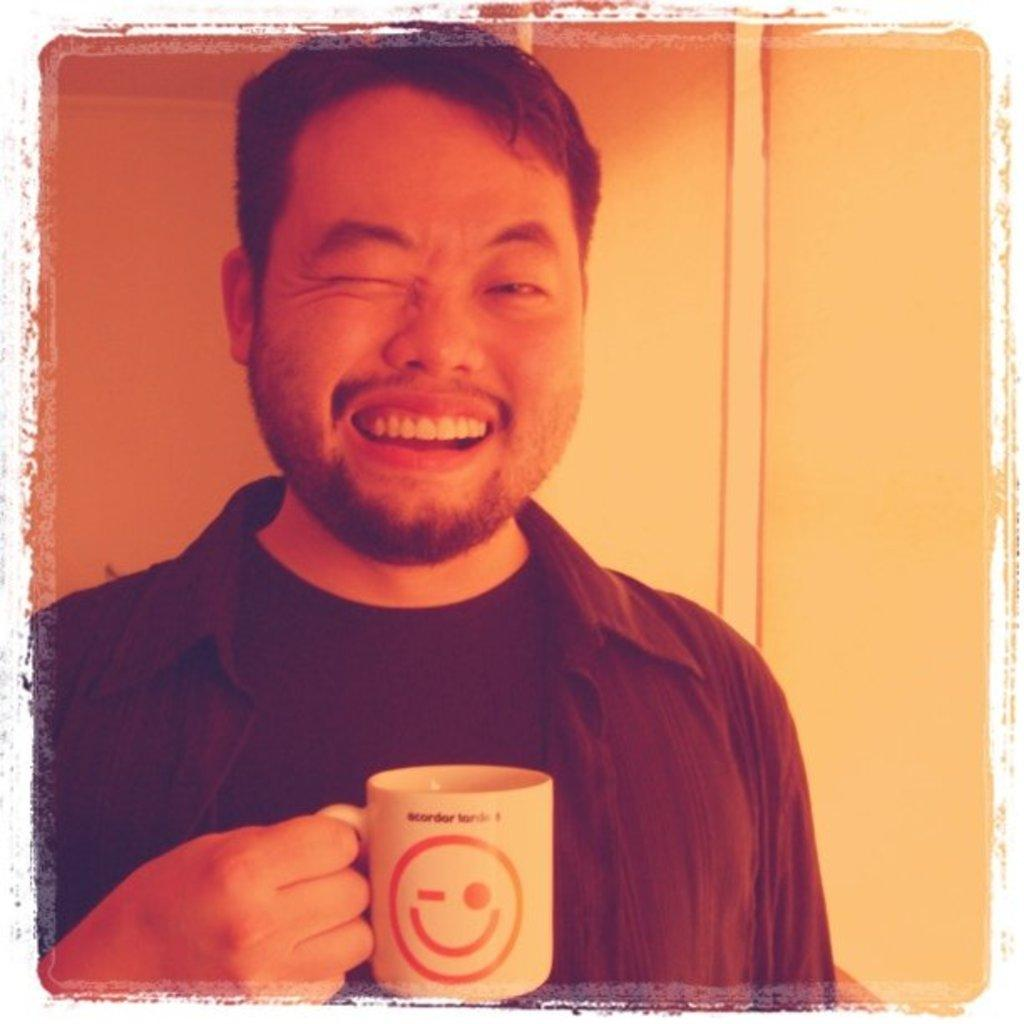Who is present in the image? There is a man in the image. What expression does the man have on his face? The man is smiling in the image. What action is the man performing with his eye? The man is winking his eye in the image. What object is the man holding in his hand? The man is holding a cup in his hand. What can be seen in the background of the image? There is a wall in the background of the image. What type of corn can be seen blowing in the wind in the image? There is no corn present in the image, nor is there any wind blowing anything. 